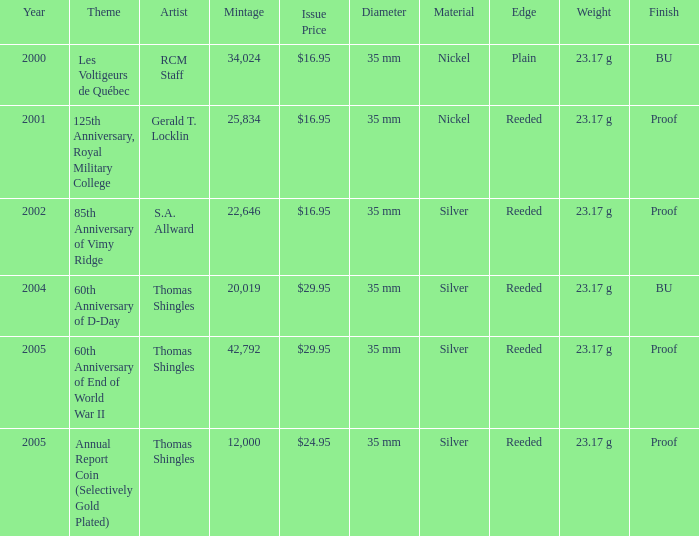I'm looking to parse the entire table for insights. Could you assist me with that? {'header': ['Year', 'Theme', 'Artist', 'Mintage', 'Issue Price', 'Diameter', 'Material', 'Edge', 'Weight', 'Finish'], 'rows': [['2000', 'Les Voltigeurs de Québec', 'RCM Staff', '34,024', '$16.95', '35 mm', 'Nickel', 'Plain', '23.17 g', 'BU'], ['2001', '125th Anniversary, Royal Military College', 'Gerald T. Locklin', '25,834', '$16.95', '35 mm', 'Nickel', 'Reeded', '23.17 g', 'Proof'], ['2002', '85th Anniversary of Vimy Ridge', 'S.A. Allward', '22,646', '$16.95', '35 mm', 'Silver', 'Reeded', '23.17 g', 'Proof'], ['2004', '60th Anniversary of D-Day', 'Thomas Shingles', '20,019', '$29.95', '35 mm', 'Silver', 'Reeded', '23.17 g', 'BU'], ['2005', '60th Anniversary of End of World War II', 'Thomas Shingles', '42,792', '$29.95', '35 mm', 'Silver', 'Reeded', '23.17 g', 'Proof'], ['2005', 'Annual Report Coin (Selectively Gold Plated)', 'Thomas Shingles', '12,000', '$24.95', '35 mm', 'Silver', 'Reeded', '23.17 g', 'Proof']]} What was the total mintage for years after 2002 that had a 85th Anniversary of Vimy Ridge theme? 0.0. 